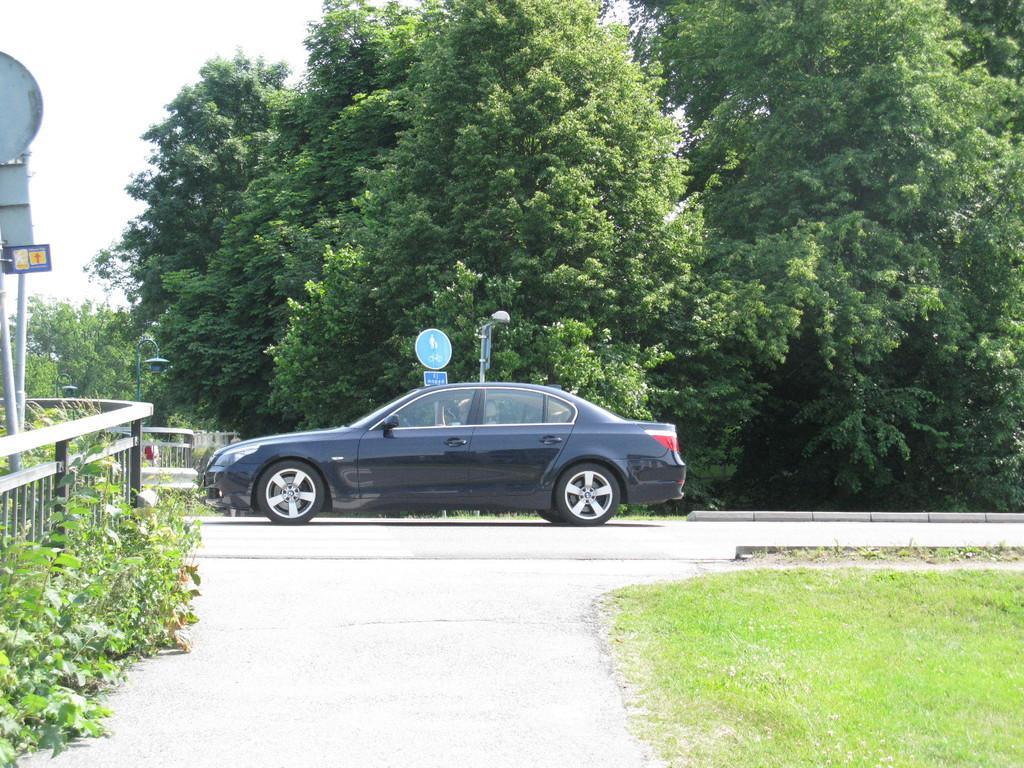Can you describe this image briefly? In this picture there is a black car on the road. On the left we can see plants, fencing, boards and pole. In the bottom right we can see the green grass. In the background we can see the street light and many trees. In the top left there is a sky. 